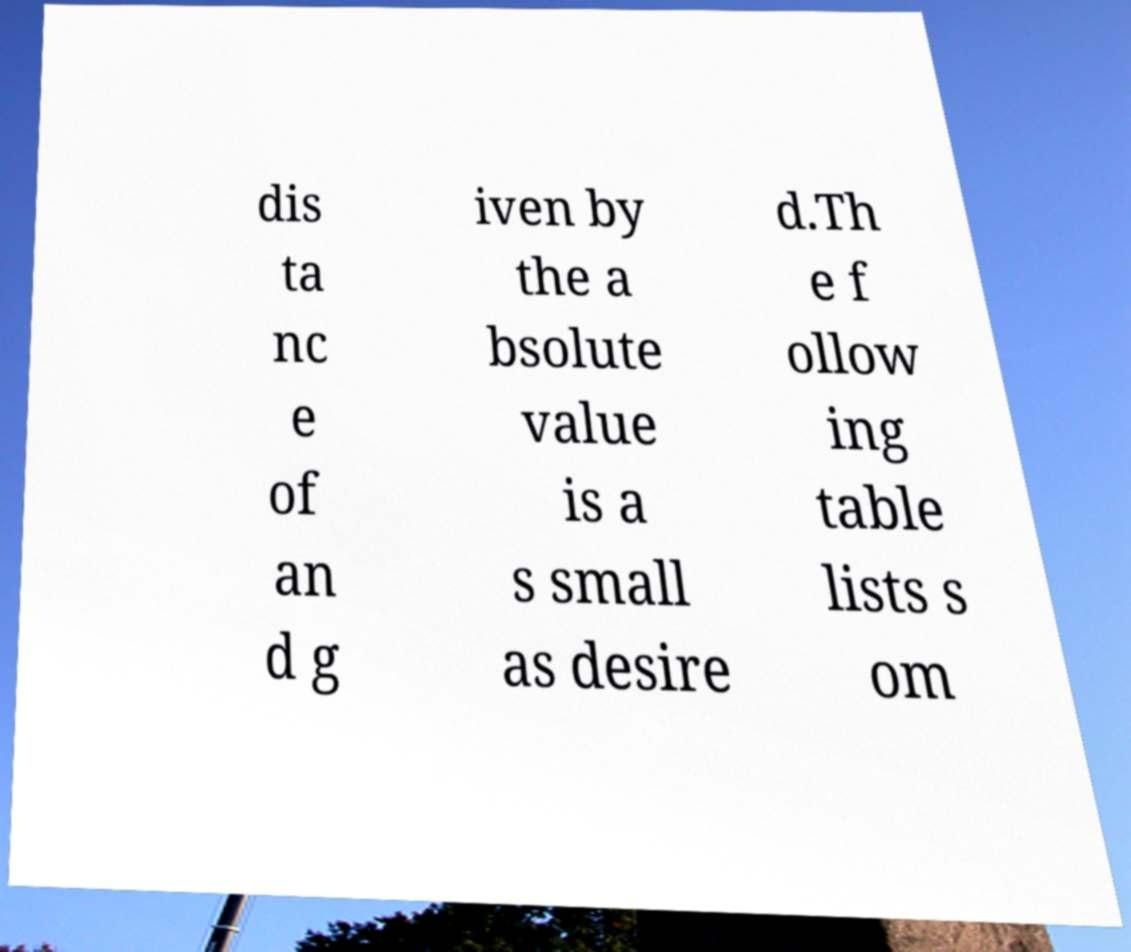What messages or text are displayed in this image? I need them in a readable, typed format. dis ta nc e of an d g iven by the a bsolute value is a s small as desire d.Th e f ollow ing table lists s om 